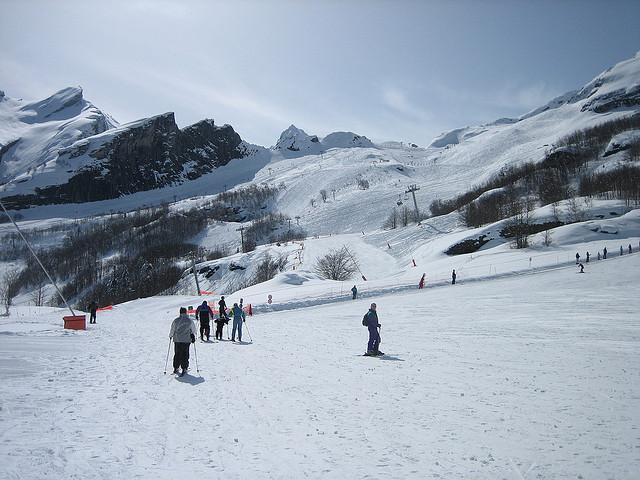What is the elevated metal railway called? Please explain your reasoning. ski lift. There is snow where people want to do snow sports at a high elevation going down. 